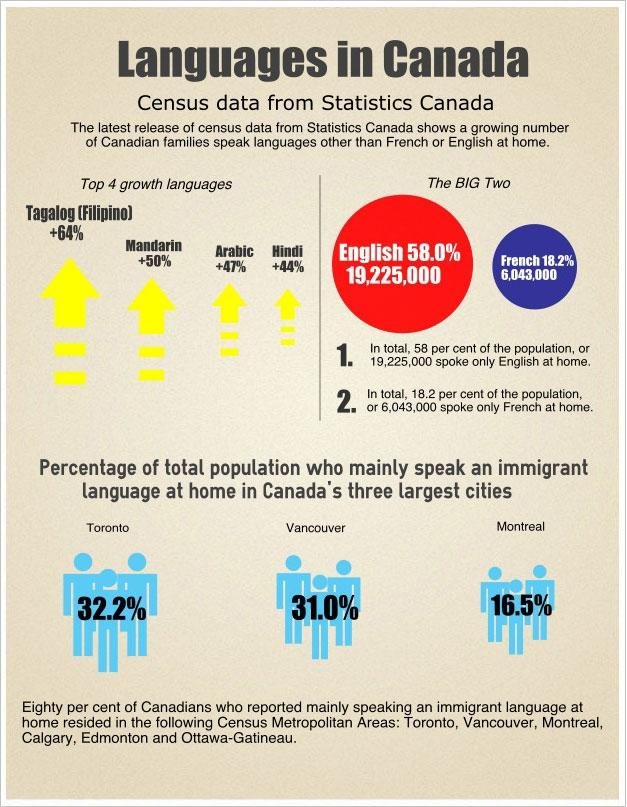Indicate a few pertinent items in this graphic. English is the language spoken by 58% of the Canadian population. In Vancouver, Canada, 31.0% of the total population primarily speak an immigrant language at home. The percentage increase in Mandarin language speaking among Canadian families is +50%. French is the language spoken by 18.2% of the Canadian population. In Toronto, the city in Canada, 32.2% of the population primarily speak an immigrant language at home. 